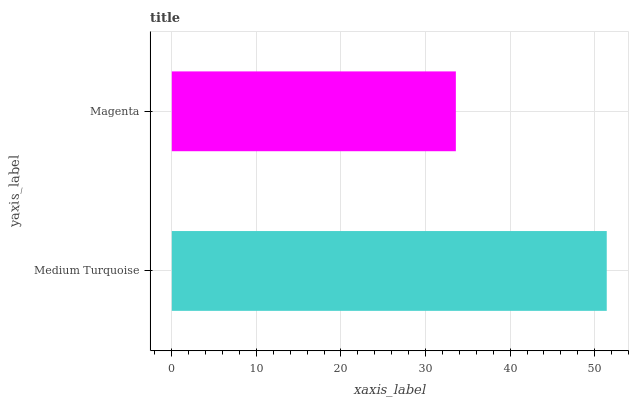Is Magenta the minimum?
Answer yes or no. Yes. Is Medium Turquoise the maximum?
Answer yes or no. Yes. Is Magenta the maximum?
Answer yes or no. No. Is Medium Turquoise greater than Magenta?
Answer yes or no. Yes. Is Magenta less than Medium Turquoise?
Answer yes or no. Yes. Is Magenta greater than Medium Turquoise?
Answer yes or no. No. Is Medium Turquoise less than Magenta?
Answer yes or no. No. Is Medium Turquoise the high median?
Answer yes or no. Yes. Is Magenta the low median?
Answer yes or no. Yes. Is Magenta the high median?
Answer yes or no. No. Is Medium Turquoise the low median?
Answer yes or no. No. 